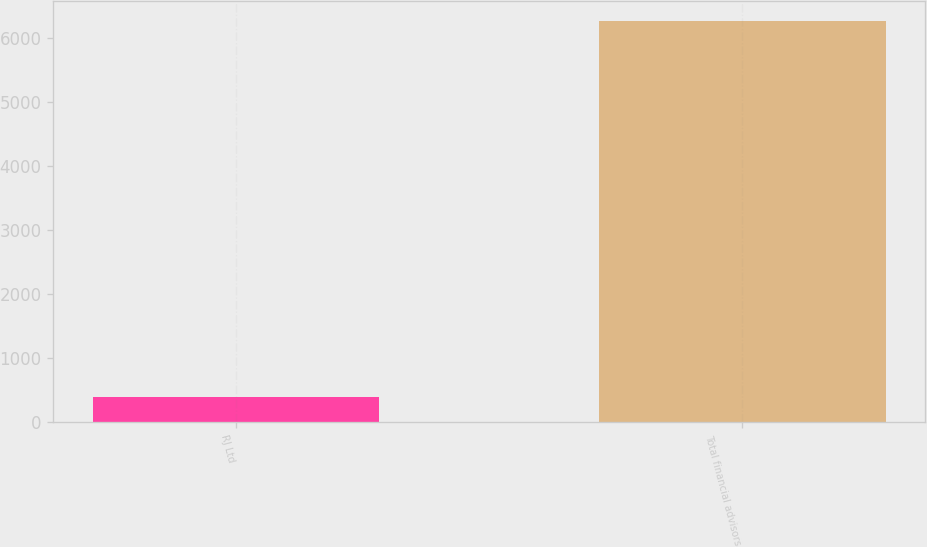Convert chart to OTSL. <chart><loc_0><loc_0><loc_500><loc_500><bar_chart><fcel>RJ Ltd<fcel>Total financial advisors<nl><fcel>391<fcel>6265<nl></chart> 